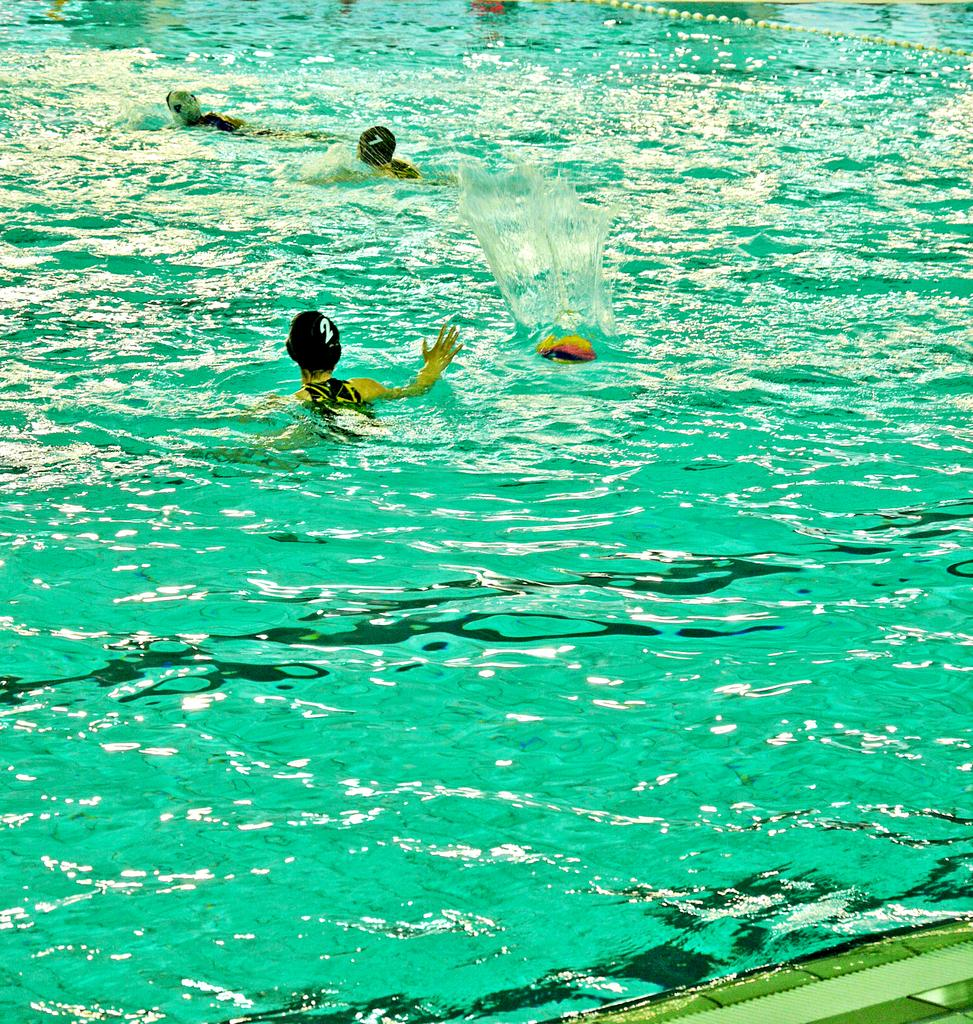What are the people in the image doing? The people in the image are in the water. What else can be seen in the image besides the people? There are objects visible in the image. What is the smell of the water in the image? The image does not provide any information about the smell of the water, so it cannot be determined from the image. 